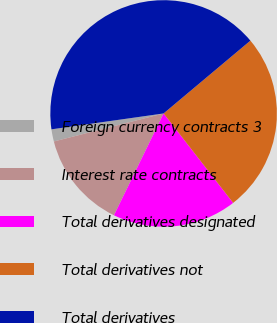Convert chart to OTSL. <chart><loc_0><loc_0><loc_500><loc_500><pie_chart><fcel>Foreign currency contracts 3<fcel>Interest rate contracts<fcel>Total derivatives designated<fcel>Total derivatives not<fcel>Total derivatives<nl><fcel>1.74%<fcel>13.8%<fcel>17.74%<fcel>25.59%<fcel>41.13%<nl></chart> 